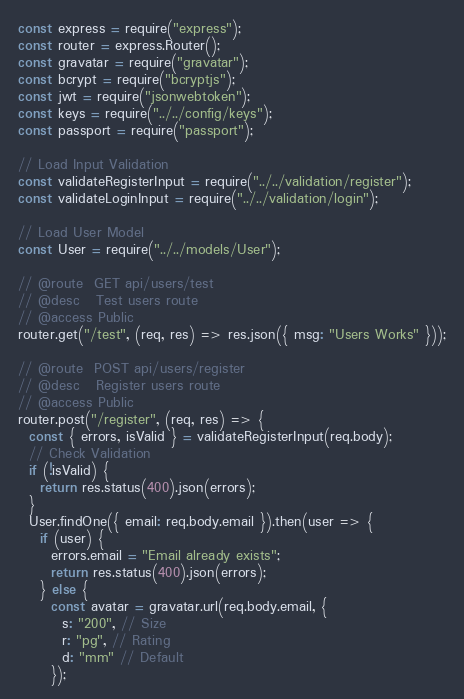<code> <loc_0><loc_0><loc_500><loc_500><_JavaScript_>const express = require("express");
const router = express.Router();
const gravatar = require("gravatar");
const bcrypt = require("bcryptjs");
const jwt = require("jsonwebtoken");
const keys = require("../../config/keys");
const passport = require("passport");

// Load Input Validation
const validateRegisterInput = require("../../validation/register");
const validateLoginInput = require("../../validation/login");

// Load User Model
const User = require("../../models/User");

// @route  GET api/users/test
// @desc   Test users route
// @access Public
router.get("/test", (req, res) => res.json({ msg: "Users Works" }));

// @route  POST api/users/register
// @desc   Register users route
// @access Public
router.post("/register", (req, res) => {
  const { errors, isValid } = validateRegisterInput(req.body);
  // Check Validation
  if (!isValid) {
    return res.status(400).json(errors);
  }
  User.findOne({ email: req.body.email }).then(user => {
    if (user) {
      errors.email = "Email already exists";
      return res.status(400).json(errors);
    } else {
      const avatar = gravatar.url(req.body.email, {
        s: "200", // Size
        r: "pg", // Rating
        d: "mm" // Default
      });</code> 